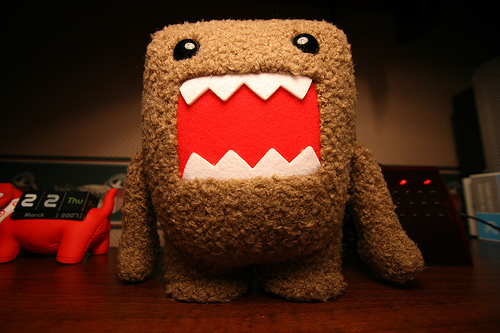<image>
Can you confirm if the domo is to the right of the date block? Yes. From this viewpoint, the domo is positioned to the right side relative to the date block. 